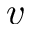<formula> <loc_0><loc_0><loc_500><loc_500>v</formula> 